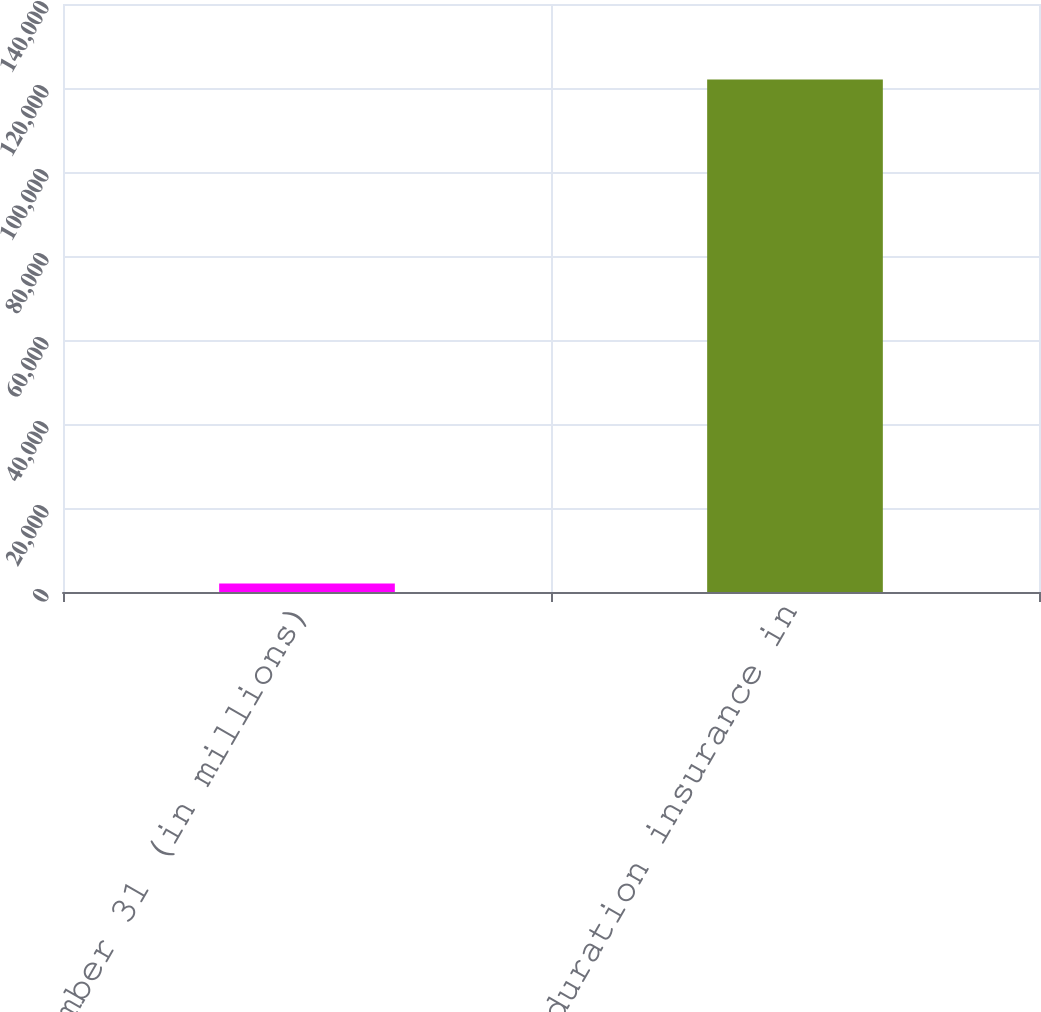Convert chart to OTSL. <chart><loc_0><loc_0><loc_500><loc_500><bar_chart><fcel>At December 31 (in millions)<fcel>Long-duration insurance in<nl><fcel>2013<fcel>122012<nl></chart> 